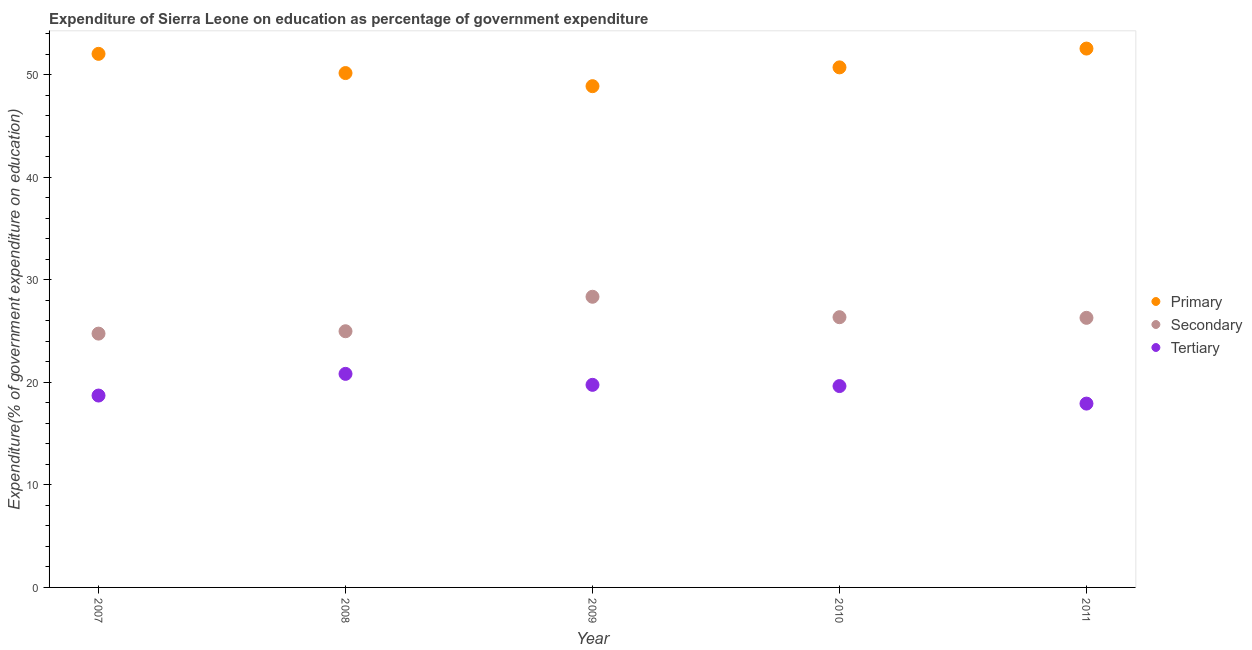How many different coloured dotlines are there?
Your answer should be compact. 3. What is the expenditure on primary education in 2007?
Keep it short and to the point. 52.04. Across all years, what is the maximum expenditure on tertiary education?
Your response must be concise. 20.83. Across all years, what is the minimum expenditure on secondary education?
Keep it short and to the point. 24.76. In which year was the expenditure on primary education maximum?
Make the answer very short. 2011. In which year was the expenditure on tertiary education minimum?
Offer a very short reply. 2011. What is the total expenditure on tertiary education in the graph?
Your answer should be compact. 96.87. What is the difference between the expenditure on primary education in 2008 and that in 2010?
Keep it short and to the point. -0.55. What is the difference between the expenditure on primary education in 2008 and the expenditure on tertiary education in 2009?
Offer a very short reply. 30.41. What is the average expenditure on secondary education per year?
Provide a short and direct response. 26.15. In the year 2008, what is the difference between the expenditure on primary education and expenditure on secondary education?
Your response must be concise. 25.18. In how many years, is the expenditure on tertiary education greater than 14 %?
Your response must be concise. 5. What is the ratio of the expenditure on secondary education in 2007 to that in 2008?
Provide a succinct answer. 0.99. Is the difference between the expenditure on primary education in 2007 and 2011 greater than the difference between the expenditure on secondary education in 2007 and 2011?
Provide a succinct answer. Yes. What is the difference between the highest and the second highest expenditure on secondary education?
Make the answer very short. 1.99. What is the difference between the highest and the lowest expenditure on primary education?
Provide a succinct answer. 3.67. In how many years, is the expenditure on primary education greater than the average expenditure on primary education taken over all years?
Keep it short and to the point. 2. Is the sum of the expenditure on tertiary education in 2007 and 2010 greater than the maximum expenditure on secondary education across all years?
Your answer should be very brief. Yes. Is it the case that in every year, the sum of the expenditure on primary education and expenditure on secondary education is greater than the expenditure on tertiary education?
Your response must be concise. Yes. Does the expenditure on tertiary education monotonically increase over the years?
Offer a very short reply. No. Is the expenditure on secondary education strictly greater than the expenditure on primary education over the years?
Provide a succinct answer. No. Is the expenditure on primary education strictly less than the expenditure on secondary education over the years?
Ensure brevity in your answer.  No. How many dotlines are there?
Your answer should be compact. 3. How many years are there in the graph?
Your response must be concise. 5. What is the difference between two consecutive major ticks on the Y-axis?
Offer a terse response. 10. Does the graph contain grids?
Keep it short and to the point. No. Where does the legend appear in the graph?
Ensure brevity in your answer.  Center right. What is the title of the graph?
Give a very brief answer. Expenditure of Sierra Leone on education as percentage of government expenditure. What is the label or title of the Y-axis?
Give a very brief answer. Expenditure(% of government expenditure on education). What is the Expenditure(% of government expenditure on education) of Primary in 2007?
Ensure brevity in your answer.  52.04. What is the Expenditure(% of government expenditure on education) in Secondary in 2007?
Ensure brevity in your answer.  24.76. What is the Expenditure(% of government expenditure on education) in Tertiary in 2007?
Provide a succinct answer. 18.71. What is the Expenditure(% of government expenditure on education) in Primary in 2008?
Keep it short and to the point. 50.17. What is the Expenditure(% of government expenditure on education) in Secondary in 2008?
Your answer should be compact. 24.99. What is the Expenditure(% of government expenditure on education) of Tertiary in 2008?
Ensure brevity in your answer.  20.83. What is the Expenditure(% of government expenditure on education) of Primary in 2009?
Your response must be concise. 48.89. What is the Expenditure(% of government expenditure on education) of Secondary in 2009?
Ensure brevity in your answer.  28.35. What is the Expenditure(% of government expenditure on education) of Tertiary in 2009?
Your answer should be compact. 19.76. What is the Expenditure(% of government expenditure on education) of Primary in 2010?
Provide a short and direct response. 50.72. What is the Expenditure(% of government expenditure on education) of Secondary in 2010?
Your response must be concise. 26.36. What is the Expenditure(% of government expenditure on education) of Tertiary in 2010?
Give a very brief answer. 19.64. What is the Expenditure(% of government expenditure on education) of Primary in 2011?
Offer a very short reply. 52.56. What is the Expenditure(% of government expenditure on education) in Secondary in 2011?
Offer a very short reply. 26.29. What is the Expenditure(% of government expenditure on education) of Tertiary in 2011?
Provide a short and direct response. 17.93. Across all years, what is the maximum Expenditure(% of government expenditure on education) in Primary?
Offer a very short reply. 52.56. Across all years, what is the maximum Expenditure(% of government expenditure on education) of Secondary?
Ensure brevity in your answer.  28.35. Across all years, what is the maximum Expenditure(% of government expenditure on education) in Tertiary?
Ensure brevity in your answer.  20.83. Across all years, what is the minimum Expenditure(% of government expenditure on education) of Primary?
Provide a succinct answer. 48.89. Across all years, what is the minimum Expenditure(% of government expenditure on education) of Secondary?
Your answer should be compact. 24.76. Across all years, what is the minimum Expenditure(% of government expenditure on education) of Tertiary?
Offer a terse response. 17.93. What is the total Expenditure(% of government expenditure on education) in Primary in the graph?
Ensure brevity in your answer.  254.38. What is the total Expenditure(% of government expenditure on education) of Secondary in the graph?
Offer a very short reply. 130.74. What is the total Expenditure(% of government expenditure on education) in Tertiary in the graph?
Keep it short and to the point. 96.87. What is the difference between the Expenditure(% of government expenditure on education) of Primary in 2007 and that in 2008?
Offer a very short reply. 1.87. What is the difference between the Expenditure(% of government expenditure on education) of Secondary in 2007 and that in 2008?
Your answer should be compact. -0.23. What is the difference between the Expenditure(% of government expenditure on education) of Tertiary in 2007 and that in 2008?
Keep it short and to the point. -2.11. What is the difference between the Expenditure(% of government expenditure on education) of Primary in 2007 and that in 2009?
Ensure brevity in your answer.  3.15. What is the difference between the Expenditure(% of government expenditure on education) in Secondary in 2007 and that in 2009?
Make the answer very short. -3.59. What is the difference between the Expenditure(% of government expenditure on education) in Tertiary in 2007 and that in 2009?
Provide a succinct answer. -1.04. What is the difference between the Expenditure(% of government expenditure on education) of Primary in 2007 and that in 2010?
Provide a succinct answer. 1.32. What is the difference between the Expenditure(% of government expenditure on education) in Secondary in 2007 and that in 2010?
Make the answer very short. -1.6. What is the difference between the Expenditure(% of government expenditure on education) of Tertiary in 2007 and that in 2010?
Give a very brief answer. -0.92. What is the difference between the Expenditure(% of government expenditure on education) in Primary in 2007 and that in 2011?
Your answer should be compact. -0.51. What is the difference between the Expenditure(% of government expenditure on education) in Secondary in 2007 and that in 2011?
Offer a terse response. -1.54. What is the difference between the Expenditure(% of government expenditure on education) in Tertiary in 2007 and that in 2011?
Provide a short and direct response. 0.78. What is the difference between the Expenditure(% of government expenditure on education) in Primary in 2008 and that in 2009?
Your answer should be compact. 1.28. What is the difference between the Expenditure(% of government expenditure on education) of Secondary in 2008 and that in 2009?
Your answer should be very brief. -3.36. What is the difference between the Expenditure(% of government expenditure on education) of Tertiary in 2008 and that in 2009?
Provide a succinct answer. 1.07. What is the difference between the Expenditure(% of government expenditure on education) in Primary in 2008 and that in 2010?
Make the answer very short. -0.55. What is the difference between the Expenditure(% of government expenditure on education) in Secondary in 2008 and that in 2010?
Provide a succinct answer. -1.37. What is the difference between the Expenditure(% of government expenditure on education) of Tertiary in 2008 and that in 2010?
Give a very brief answer. 1.19. What is the difference between the Expenditure(% of government expenditure on education) of Primary in 2008 and that in 2011?
Your answer should be compact. -2.39. What is the difference between the Expenditure(% of government expenditure on education) in Secondary in 2008 and that in 2011?
Keep it short and to the point. -1.31. What is the difference between the Expenditure(% of government expenditure on education) of Tertiary in 2008 and that in 2011?
Keep it short and to the point. 2.9. What is the difference between the Expenditure(% of government expenditure on education) in Primary in 2009 and that in 2010?
Give a very brief answer. -1.83. What is the difference between the Expenditure(% of government expenditure on education) in Secondary in 2009 and that in 2010?
Offer a terse response. 1.99. What is the difference between the Expenditure(% of government expenditure on education) of Tertiary in 2009 and that in 2010?
Provide a short and direct response. 0.12. What is the difference between the Expenditure(% of government expenditure on education) in Primary in 2009 and that in 2011?
Ensure brevity in your answer.  -3.67. What is the difference between the Expenditure(% of government expenditure on education) in Secondary in 2009 and that in 2011?
Provide a succinct answer. 2.06. What is the difference between the Expenditure(% of government expenditure on education) in Tertiary in 2009 and that in 2011?
Your answer should be very brief. 1.83. What is the difference between the Expenditure(% of government expenditure on education) of Primary in 2010 and that in 2011?
Give a very brief answer. -1.83. What is the difference between the Expenditure(% of government expenditure on education) in Secondary in 2010 and that in 2011?
Make the answer very short. 0.06. What is the difference between the Expenditure(% of government expenditure on education) in Tertiary in 2010 and that in 2011?
Your answer should be very brief. 1.71. What is the difference between the Expenditure(% of government expenditure on education) of Primary in 2007 and the Expenditure(% of government expenditure on education) of Secondary in 2008?
Provide a short and direct response. 27.05. What is the difference between the Expenditure(% of government expenditure on education) of Primary in 2007 and the Expenditure(% of government expenditure on education) of Tertiary in 2008?
Ensure brevity in your answer.  31.21. What is the difference between the Expenditure(% of government expenditure on education) in Secondary in 2007 and the Expenditure(% of government expenditure on education) in Tertiary in 2008?
Provide a succinct answer. 3.93. What is the difference between the Expenditure(% of government expenditure on education) in Primary in 2007 and the Expenditure(% of government expenditure on education) in Secondary in 2009?
Provide a succinct answer. 23.69. What is the difference between the Expenditure(% of government expenditure on education) in Primary in 2007 and the Expenditure(% of government expenditure on education) in Tertiary in 2009?
Make the answer very short. 32.28. What is the difference between the Expenditure(% of government expenditure on education) in Secondary in 2007 and the Expenditure(% of government expenditure on education) in Tertiary in 2009?
Make the answer very short. 5. What is the difference between the Expenditure(% of government expenditure on education) of Primary in 2007 and the Expenditure(% of government expenditure on education) of Secondary in 2010?
Provide a short and direct response. 25.69. What is the difference between the Expenditure(% of government expenditure on education) in Primary in 2007 and the Expenditure(% of government expenditure on education) in Tertiary in 2010?
Your answer should be compact. 32.4. What is the difference between the Expenditure(% of government expenditure on education) in Secondary in 2007 and the Expenditure(% of government expenditure on education) in Tertiary in 2010?
Give a very brief answer. 5.12. What is the difference between the Expenditure(% of government expenditure on education) in Primary in 2007 and the Expenditure(% of government expenditure on education) in Secondary in 2011?
Offer a very short reply. 25.75. What is the difference between the Expenditure(% of government expenditure on education) in Primary in 2007 and the Expenditure(% of government expenditure on education) in Tertiary in 2011?
Make the answer very short. 34.11. What is the difference between the Expenditure(% of government expenditure on education) of Secondary in 2007 and the Expenditure(% of government expenditure on education) of Tertiary in 2011?
Your answer should be very brief. 6.83. What is the difference between the Expenditure(% of government expenditure on education) in Primary in 2008 and the Expenditure(% of government expenditure on education) in Secondary in 2009?
Provide a short and direct response. 21.82. What is the difference between the Expenditure(% of government expenditure on education) in Primary in 2008 and the Expenditure(% of government expenditure on education) in Tertiary in 2009?
Ensure brevity in your answer.  30.41. What is the difference between the Expenditure(% of government expenditure on education) of Secondary in 2008 and the Expenditure(% of government expenditure on education) of Tertiary in 2009?
Your answer should be compact. 5.23. What is the difference between the Expenditure(% of government expenditure on education) of Primary in 2008 and the Expenditure(% of government expenditure on education) of Secondary in 2010?
Ensure brevity in your answer.  23.81. What is the difference between the Expenditure(% of government expenditure on education) in Primary in 2008 and the Expenditure(% of government expenditure on education) in Tertiary in 2010?
Your answer should be compact. 30.53. What is the difference between the Expenditure(% of government expenditure on education) of Secondary in 2008 and the Expenditure(% of government expenditure on education) of Tertiary in 2010?
Provide a succinct answer. 5.35. What is the difference between the Expenditure(% of government expenditure on education) in Primary in 2008 and the Expenditure(% of government expenditure on education) in Secondary in 2011?
Offer a terse response. 23.87. What is the difference between the Expenditure(% of government expenditure on education) of Primary in 2008 and the Expenditure(% of government expenditure on education) of Tertiary in 2011?
Provide a succinct answer. 32.24. What is the difference between the Expenditure(% of government expenditure on education) in Secondary in 2008 and the Expenditure(% of government expenditure on education) in Tertiary in 2011?
Give a very brief answer. 7.06. What is the difference between the Expenditure(% of government expenditure on education) of Primary in 2009 and the Expenditure(% of government expenditure on education) of Secondary in 2010?
Ensure brevity in your answer.  22.53. What is the difference between the Expenditure(% of government expenditure on education) of Primary in 2009 and the Expenditure(% of government expenditure on education) of Tertiary in 2010?
Your answer should be very brief. 29.25. What is the difference between the Expenditure(% of government expenditure on education) of Secondary in 2009 and the Expenditure(% of government expenditure on education) of Tertiary in 2010?
Keep it short and to the point. 8.71. What is the difference between the Expenditure(% of government expenditure on education) in Primary in 2009 and the Expenditure(% of government expenditure on education) in Secondary in 2011?
Your response must be concise. 22.6. What is the difference between the Expenditure(% of government expenditure on education) of Primary in 2009 and the Expenditure(% of government expenditure on education) of Tertiary in 2011?
Make the answer very short. 30.96. What is the difference between the Expenditure(% of government expenditure on education) of Secondary in 2009 and the Expenditure(% of government expenditure on education) of Tertiary in 2011?
Make the answer very short. 10.42. What is the difference between the Expenditure(% of government expenditure on education) in Primary in 2010 and the Expenditure(% of government expenditure on education) in Secondary in 2011?
Provide a short and direct response. 24.43. What is the difference between the Expenditure(% of government expenditure on education) of Primary in 2010 and the Expenditure(% of government expenditure on education) of Tertiary in 2011?
Offer a very short reply. 32.79. What is the difference between the Expenditure(% of government expenditure on education) of Secondary in 2010 and the Expenditure(% of government expenditure on education) of Tertiary in 2011?
Your response must be concise. 8.43. What is the average Expenditure(% of government expenditure on education) of Primary per year?
Your response must be concise. 50.88. What is the average Expenditure(% of government expenditure on education) of Secondary per year?
Provide a succinct answer. 26.15. What is the average Expenditure(% of government expenditure on education) in Tertiary per year?
Ensure brevity in your answer.  19.37. In the year 2007, what is the difference between the Expenditure(% of government expenditure on education) in Primary and Expenditure(% of government expenditure on education) in Secondary?
Give a very brief answer. 27.29. In the year 2007, what is the difference between the Expenditure(% of government expenditure on education) of Primary and Expenditure(% of government expenditure on education) of Tertiary?
Make the answer very short. 33.33. In the year 2007, what is the difference between the Expenditure(% of government expenditure on education) in Secondary and Expenditure(% of government expenditure on education) in Tertiary?
Give a very brief answer. 6.04. In the year 2008, what is the difference between the Expenditure(% of government expenditure on education) of Primary and Expenditure(% of government expenditure on education) of Secondary?
Keep it short and to the point. 25.18. In the year 2008, what is the difference between the Expenditure(% of government expenditure on education) in Primary and Expenditure(% of government expenditure on education) in Tertiary?
Keep it short and to the point. 29.34. In the year 2008, what is the difference between the Expenditure(% of government expenditure on education) in Secondary and Expenditure(% of government expenditure on education) in Tertiary?
Give a very brief answer. 4.16. In the year 2009, what is the difference between the Expenditure(% of government expenditure on education) of Primary and Expenditure(% of government expenditure on education) of Secondary?
Your answer should be very brief. 20.54. In the year 2009, what is the difference between the Expenditure(% of government expenditure on education) in Primary and Expenditure(% of government expenditure on education) in Tertiary?
Offer a terse response. 29.13. In the year 2009, what is the difference between the Expenditure(% of government expenditure on education) in Secondary and Expenditure(% of government expenditure on education) in Tertiary?
Provide a short and direct response. 8.59. In the year 2010, what is the difference between the Expenditure(% of government expenditure on education) in Primary and Expenditure(% of government expenditure on education) in Secondary?
Your response must be concise. 24.37. In the year 2010, what is the difference between the Expenditure(% of government expenditure on education) in Primary and Expenditure(% of government expenditure on education) in Tertiary?
Provide a short and direct response. 31.08. In the year 2010, what is the difference between the Expenditure(% of government expenditure on education) of Secondary and Expenditure(% of government expenditure on education) of Tertiary?
Your answer should be very brief. 6.72. In the year 2011, what is the difference between the Expenditure(% of government expenditure on education) in Primary and Expenditure(% of government expenditure on education) in Secondary?
Offer a terse response. 26.26. In the year 2011, what is the difference between the Expenditure(% of government expenditure on education) in Primary and Expenditure(% of government expenditure on education) in Tertiary?
Ensure brevity in your answer.  34.63. In the year 2011, what is the difference between the Expenditure(% of government expenditure on education) of Secondary and Expenditure(% of government expenditure on education) of Tertiary?
Your answer should be compact. 8.36. What is the ratio of the Expenditure(% of government expenditure on education) of Primary in 2007 to that in 2008?
Keep it short and to the point. 1.04. What is the ratio of the Expenditure(% of government expenditure on education) of Tertiary in 2007 to that in 2008?
Your response must be concise. 0.9. What is the ratio of the Expenditure(% of government expenditure on education) in Primary in 2007 to that in 2009?
Ensure brevity in your answer.  1.06. What is the ratio of the Expenditure(% of government expenditure on education) in Secondary in 2007 to that in 2009?
Give a very brief answer. 0.87. What is the ratio of the Expenditure(% of government expenditure on education) in Tertiary in 2007 to that in 2009?
Make the answer very short. 0.95. What is the ratio of the Expenditure(% of government expenditure on education) in Secondary in 2007 to that in 2010?
Keep it short and to the point. 0.94. What is the ratio of the Expenditure(% of government expenditure on education) in Tertiary in 2007 to that in 2010?
Offer a very short reply. 0.95. What is the ratio of the Expenditure(% of government expenditure on education) of Primary in 2007 to that in 2011?
Your answer should be very brief. 0.99. What is the ratio of the Expenditure(% of government expenditure on education) in Secondary in 2007 to that in 2011?
Your response must be concise. 0.94. What is the ratio of the Expenditure(% of government expenditure on education) of Tertiary in 2007 to that in 2011?
Offer a terse response. 1.04. What is the ratio of the Expenditure(% of government expenditure on education) of Primary in 2008 to that in 2009?
Provide a short and direct response. 1.03. What is the ratio of the Expenditure(% of government expenditure on education) of Secondary in 2008 to that in 2009?
Offer a very short reply. 0.88. What is the ratio of the Expenditure(% of government expenditure on education) of Tertiary in 2008 to that in 2009?
Your answer should be very brief. 1.05. What is the ratio of the Expenditure(% of government expenditure on education) in Secondary in 2008 to that in 2010?
Your answer should be compact. 0.95. What is the ratio of the Expenditure(% of government expenditure on education) of Tertiary in 2008 to that in 2010?
Give a very brief answer. 1.06. What is the ratio of the Expenditure(% of government expenditure on education) in Primary in 2008 to that in 2011?
Your answer should be compact. 0.95. What is the ratio of the Expenditure(% of government expenditure on education) in Secondary in 2008 to that in 2011?
Provide a succinct answer. 0.95. What is the ratio of the Expenditure(% of government expenditure on education) of Tertiary in 2008 to that in 2011?
Keep it short and to the point. 1.16. What is the ratio of the Expenditure(% of government expenditure on education) of Primary in 2009 to that in 2010?
Keep it short and to the point. 0.96. What is the ratio of the Expenditure(% of government expenditure on education) in Secondary in 2009 to that in 2010?
Keep it short and to the point. 1.08. What is the ratio of the Expenditure(% of government expenditure on education) in Tertiary in 2009 to that in 2010?
Your answer should be compact. 1.01. What is the ratio of the Expenditure(% of government expenditure on education) in Primary in 2009 to that in 2011?
Make the answer very short. 0.93. What is the ratio of the Expenditure(% of government expenditure on education) of Secondary in 2009 to that in 2011?
Provide a short and direct response. 1.08. What is the ratio of the Expenditure(% of government expenditure on education) in Tertiary in 2009 to that in 2011?
Ensure brevity in your answer.  1.1. What is the ratio of the Expenditure(% of government expenditure on education) of Primary in 2010 to that in 2011?
Your answer should be compact. 0.97. What is the ratio of the Expenditure(% of government expenditure on education) of Secondary in 2010 to that in 2011?
Give a very brief answer. 1. What is the ratio of the Expenditure(% of government expenditure on education) in Tertiary in 2010 to that in 2011?
Your response must be concise. 1.1. What is the difference between the highest and the second highest Expenditure(% of government expenditure on education) of Primary?
Ensure brevity in your answer.  0.51. What is the difference between the highest and the second highest Expenditure(% of government expenditure on education) in Secondary?
Ensure brevity in your answer.  1.99. What is the difference between the highest and the second highest Expenditure(% of government expenditure on education) in Tertiary?
Make the answer very short. 1.07. What is the difference between the highest and the lowest Expenditure(% of government expenditure on education) in Primary?
Keep it short and to the point. 3.67. What is the difference between the highest and the lowest Expenditure(% of government expenditure on education) in Secondary?
Offer a terse response. 3.59. What is the difference between the highest and the lowest Expenditure(% of government expenditure on education) of Tertiary?
Your answer should be compact. 2.9. 